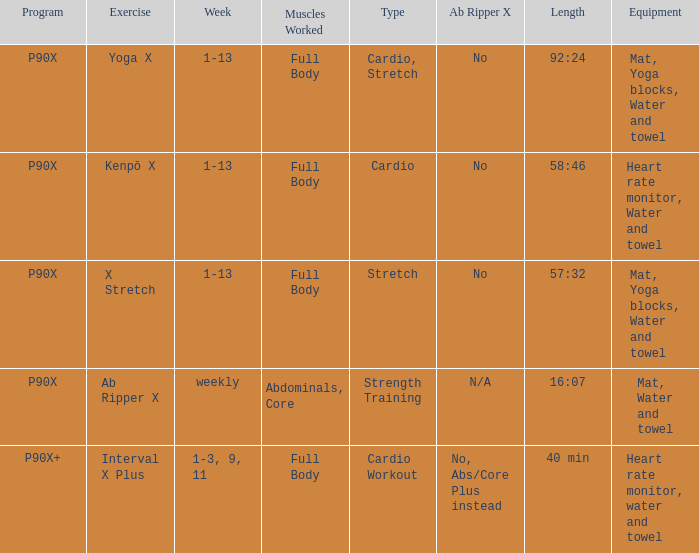What is the week when type is cardio workout? 1-3, 9, 11. 